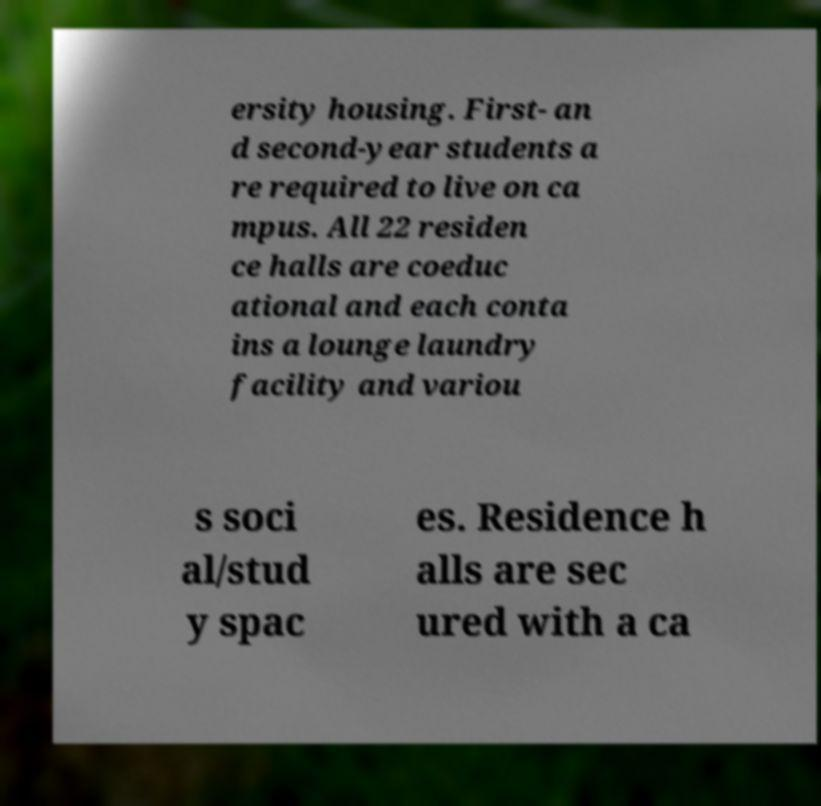Can you accurately transcribe the text from the provided image for me? ersity housing. First- an d second-year students a re required to live on ca mpus. All 22 residen ce halls are coeduc ational and each conta ins a lounge laundry facility and variou s soci al/stud y spac es. Residence h alls are sec ured with a ca 